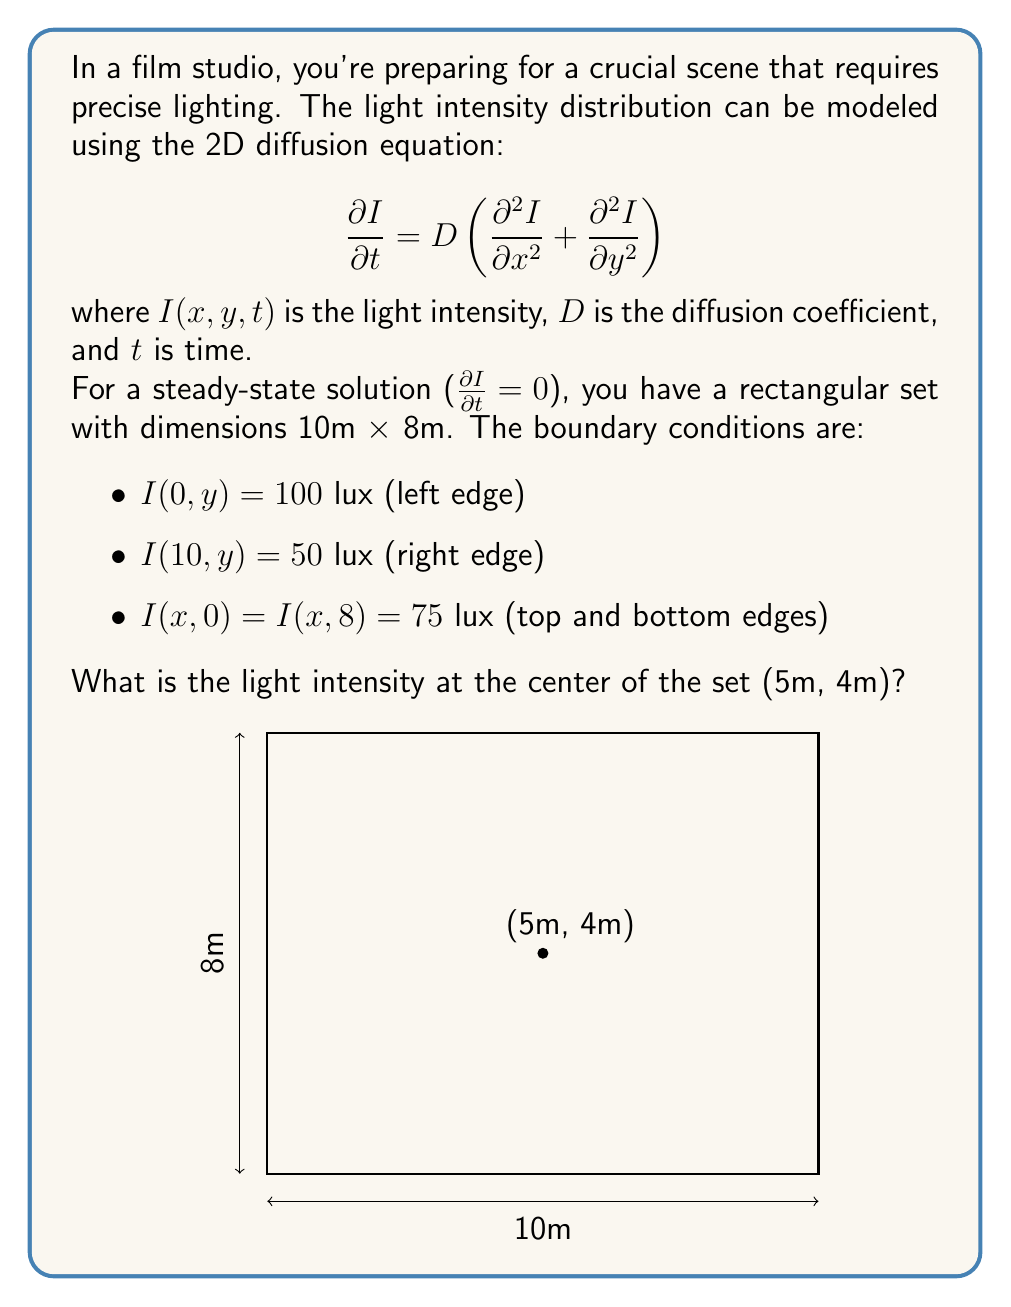Teach me how to tackle this problem. To solve this problem, we need to use the steady-state 2D diffusion equation:

$$\frac{\partial^2 I}{\partial x^2} + \frac{\partial^2 I}{\partial y^2} = 0$$

For a rectangular domain with the given boundary conditions, the solution can be expressed as a series:

$$I(x,y) = \sum_{n=1}^{\infty} A_n \sinh(\frac{n\pi x}{8}) \sin(\frac{n\pi y}{8}) + B_n \sinh(\frac{n\pi (10-x)}{8}) \sin(\frac{n\pi y}{8}) + 75$$

where $A_n$ and $B_n$ are coefficients determined by the boundary conditions.

To simplify, we can approximate the solution using only the first term of the series:

$$I(x,y) \approx A_1 \sinh(\frac{\pi x}{8}) \sin(\frac{\pi y}{8}) + B_1 \sinh(\frac{\pi (10-x)}{8}) \sin(\frac{\pi y}{8}) + 75$$

Applying the boundary conditions:

At $x = 0$: $100 = B_1 \sinh(\frac{10\pi}{8}) \sin(\frac{\pi y}{8}) + 75$
At $x = 10$: $50 = A_1 \sinh(\frac{10\pi}{8}) \sin(\frac{\pi y}{8}) + 75$

Solving these equations:

$A_1 = -\frac{25}{\sinh(\frac{10\pi}{8})}$, $B_1 = \frac{25}{\sinh(\frac{10\pi}{8})}$

Now, we can calculate the intensity at the center (5m, 4m):

$$I(5,4) \approx -\frac{25}{\sinh(\frac{10\pi}{8})} \sinh(\frac{5\pi}{8}) \sin(\frac{\pi}{2}) + \frac{25}{\sinh(\frac{10\pi}{8})} \sinh(\frac{5\pi}{8}) \sin(\frac{\pi}{2}) + 75$$

$$I(5,4) \approx 75$$

Therefore, the light intensity at the center of the set is approximately 75 lux.
Answer: 75 lux 